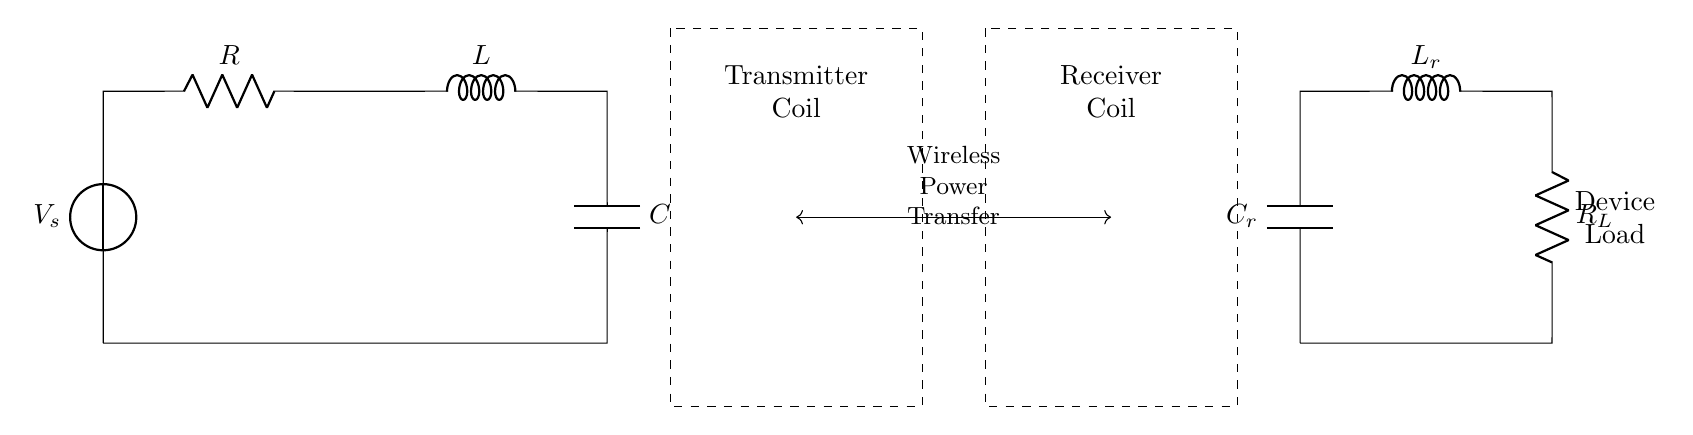What is the main electrical source in this circuit? The main electrical source is the voltage source labeled as V_s, which provides the necessary potential difference for the circuit to operate.
Answer: V_s What are the components used in the wireless power transfer circuit? The components of the circuit include a resistor (R), inductor (L), capacitor (C), receiver capacitor (C_r), receiver inductor (L_r), and a load resistor (R_L).
Answer: R, L, C, C_r, L_r, R_L How many inductors are present in the circuit? There are two inductors in the circuit, one in the transmitter section (L) and one in the receiver section (L_r).
Answer: 2 What is the function of the dashed rectangles in the circuit? The dashed rectangles signify the presence of coils; the left rectangle represents the transmitter coil, while the right rectangle represents the receiver coil, which are used for wireless power transfer.
Answer: Coils Explain the purpose of the capacitor in this circuit. The capacitor (C) in the circuit is crucial for tuning the resonant frequency of the RLC circuit, which helps maximize energy transfer to the load; it stores and releases energy as the circuit oscillates.
Answer: Energy storage What type of circuit is depicted and what is its main application? The circuit is an RLC circuit, primarily used for wireless power transfer in charging electronic devices; it facilitates efficient energy transmission through inductive coupling between coils.
Answer: RLC circuit What role does the load resistor play in the circuit? The load resistor (R_L) receives power from the circuit and converts electrical energy into usable energy for the device that is being charged, thus allowing for practical use of the transmitted power.
Answer: Power conversion 